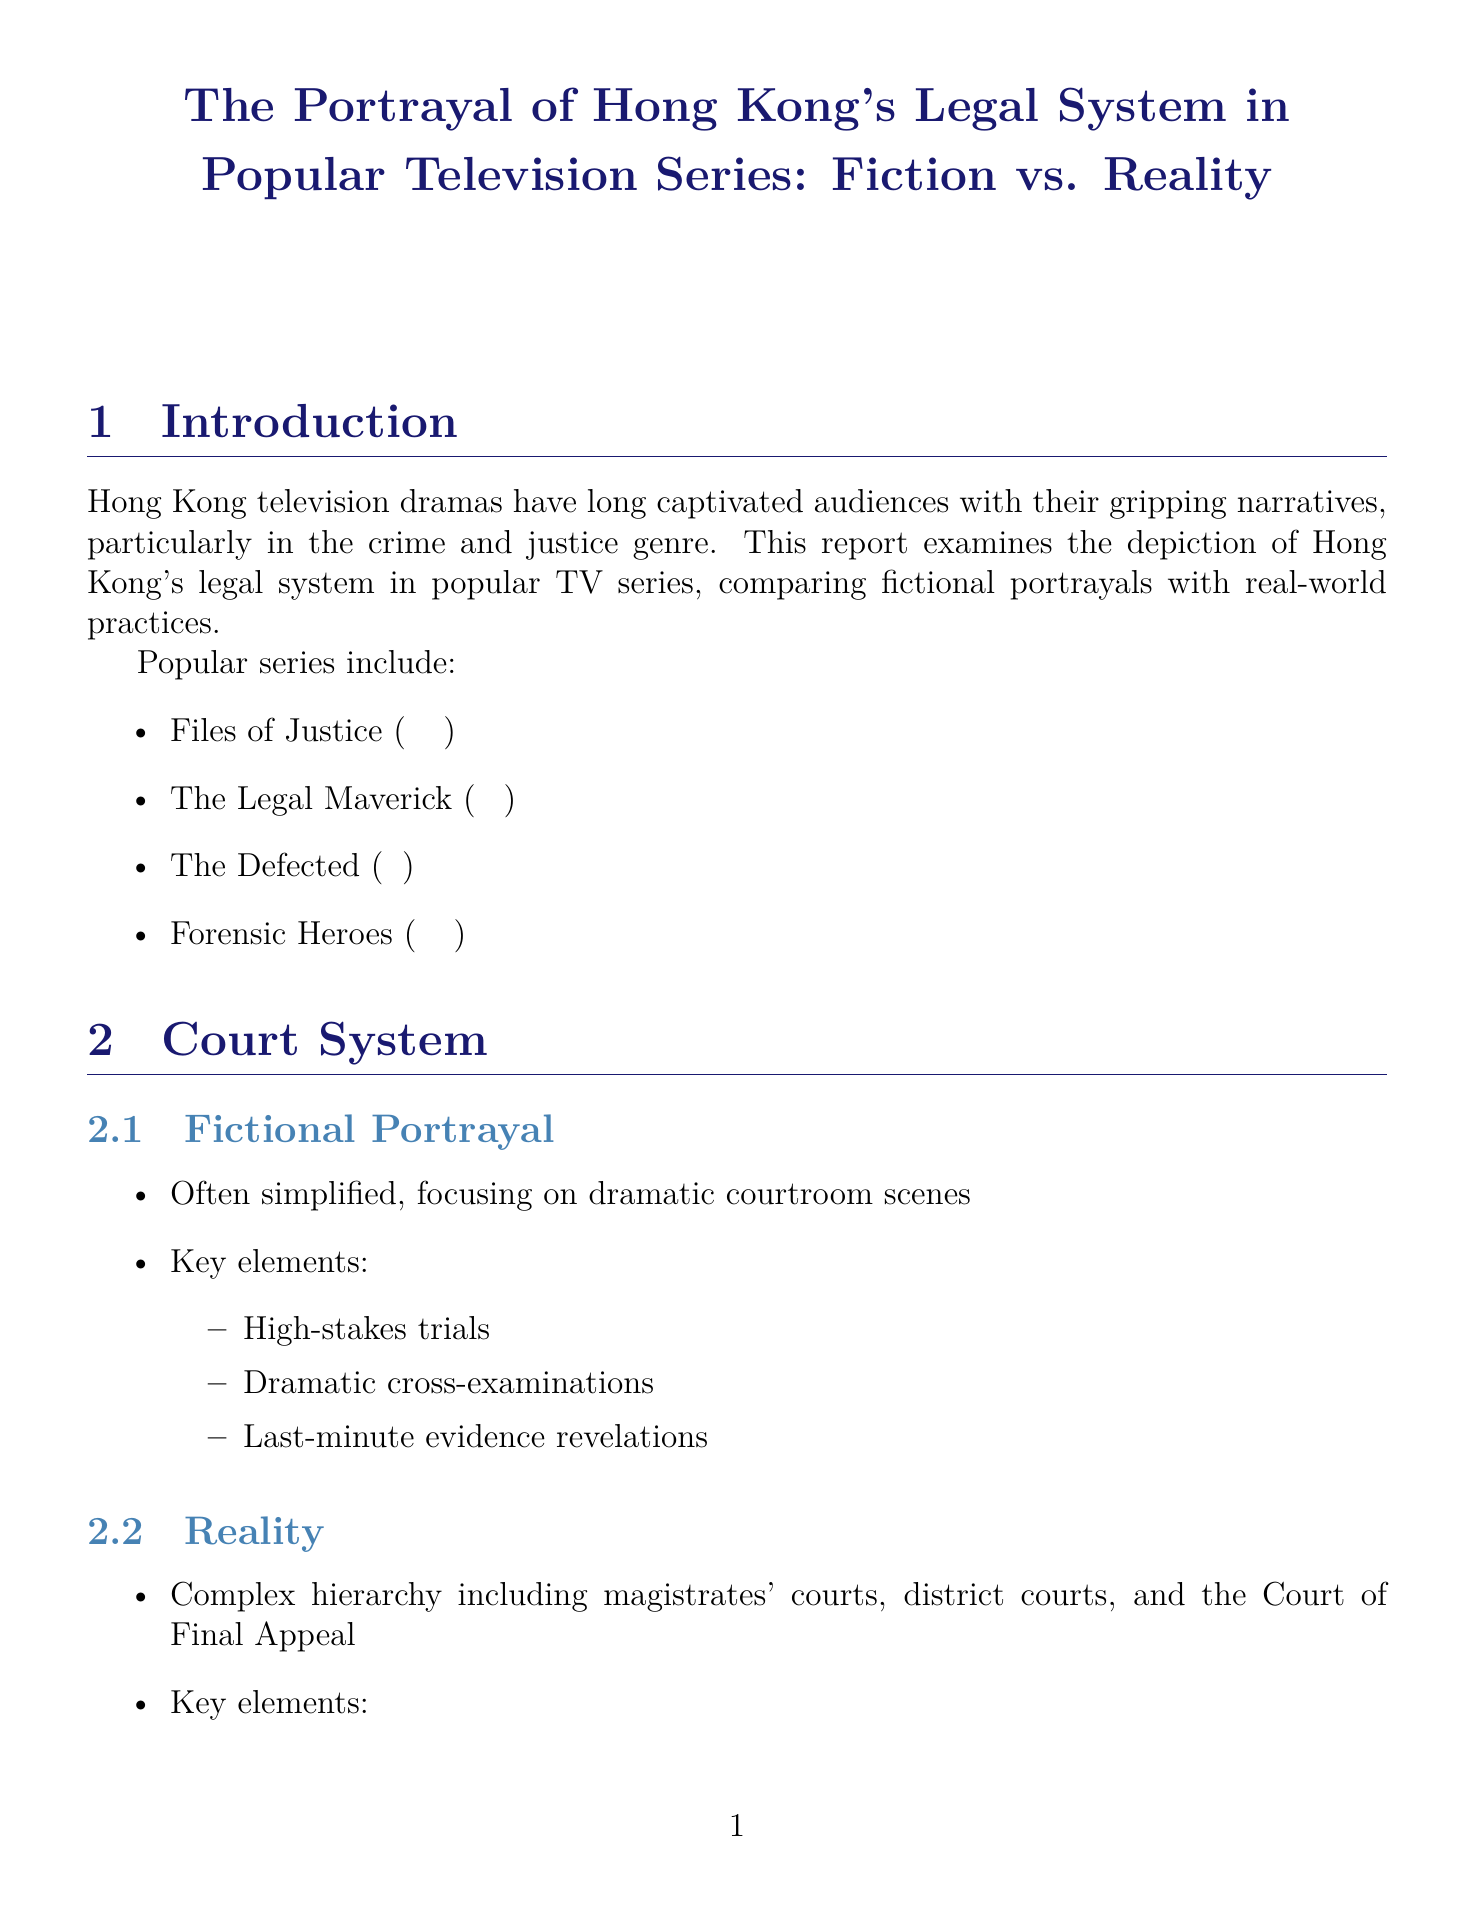What is the title of the report? The title of the report provides the main subject and is explicitly stated at the beginning of the document.
Answer: The Portrayal of Hong Kong's Legal System in Popular Television Series: Fiction vs. Reality Which series is mentioned first in the popular series section? The popular series section lists the series in a specific order, and the first one mentioned is the first in the list.
Answer: Files of Justice (壹號皇庭) What is a key element of the fictional portrayal of the court system? The document outlines several key elements specific to the fictional portrayal of the court system, one of which is highlighted.
Answer: High-stakes trials Name one example of a character portrayed as a lawyer in a series. The report provides specific examples of characters in the fictional portrayal of legal professionals, including their names and the series.
Answer: Lok Bun (樂斌) in 'The Legal Maverick' What department is mentioned as part of the investigation process in reality? The reality section lists key departments involved in the investigation process, one of which serves as an example.
Answer: Hong Kong Police Force What is one positive aspect of the impact on public perception? The document discusses various positive aspects regarding the impact on public perception of the legal system portrayed in dramas.
Answer: Increased interest in legal careers According to the report, what should viewers understand about fictional portrayals? The conclusion summarizes the report's stance on how viewers should perceive the fictional portrayals of the legal system in dramas.
Answer: Their fictional nature What is one recommendation for public engagement mentioned in the conclusion? The conclusion provides specific recommendations aimed at improving public engagement with the legal system, including potential actions for media makers and the public.
Answer: Promote public legal education initiatives 